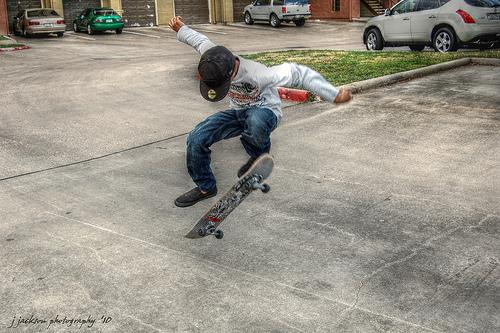Question: what else is in the photo?
Choices:
A. Road.
B. Cars.
C. A truck.
D. Tools.
Answer with the letter. Answer: A Question: where is this scene?
Choices:
A. Airport.
B. Shopping mall.
C. Parking lot.
D. Sidewalk.
Answer with the letter. Answer: C Question: who is in the photo?
Choices:
A. Person.
B. An old man.
C. A boy.
D. Children.
Answer with the letter. Answer: A Question: why is the boy suspended?
Choices:
A. Doing a trick.
B. Misbehaving.
C. For lying.
D. For cheating.
Answer with the letter. Answer: A Question: what is he using?
Choices:
A. Bicycle.
B. Fishing rod.
C. Skateboard.
D. A hammer.
Answer with the letter. Answer: C 